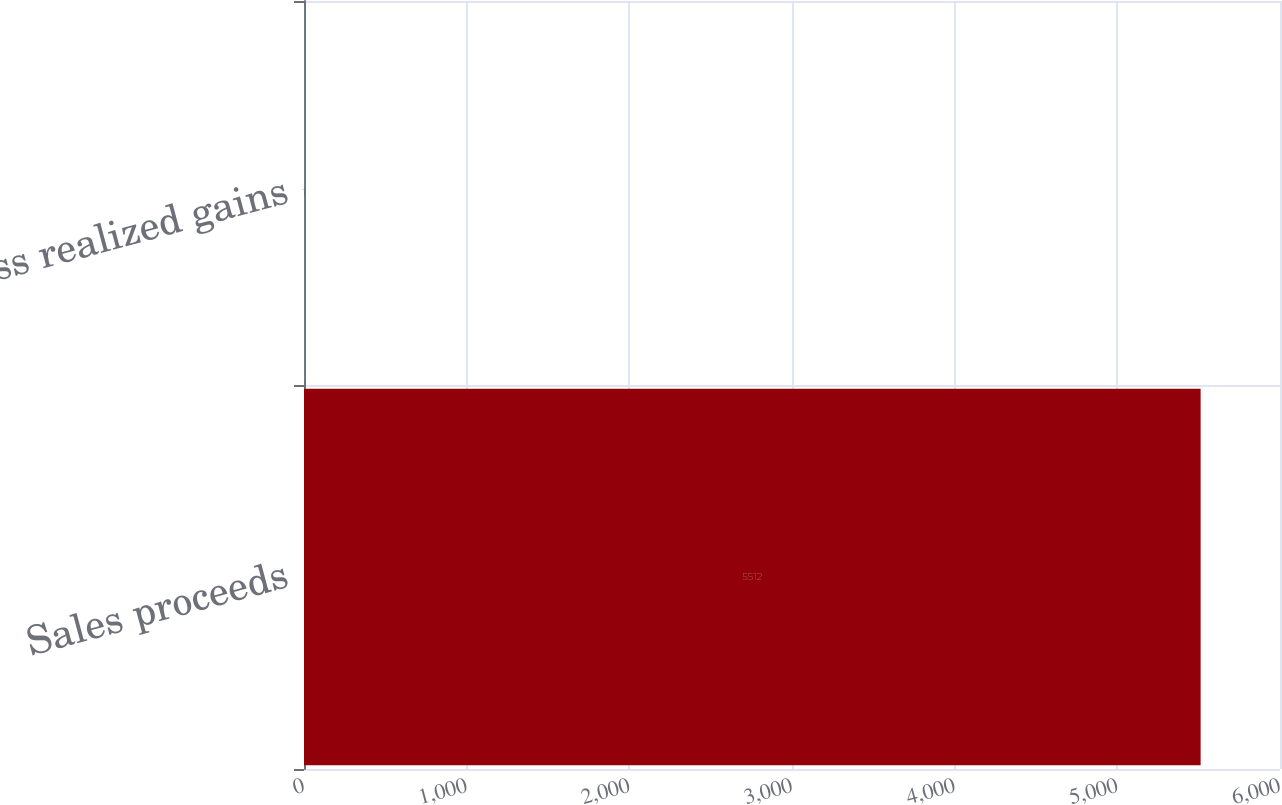<chart> <loc_0><loc_0><loc_500><loc_500><bar_chart><fcel>Sales proceeds<fcel>Gross realized gains<nl><fcel>5512<fcel>1<nl></chart> 